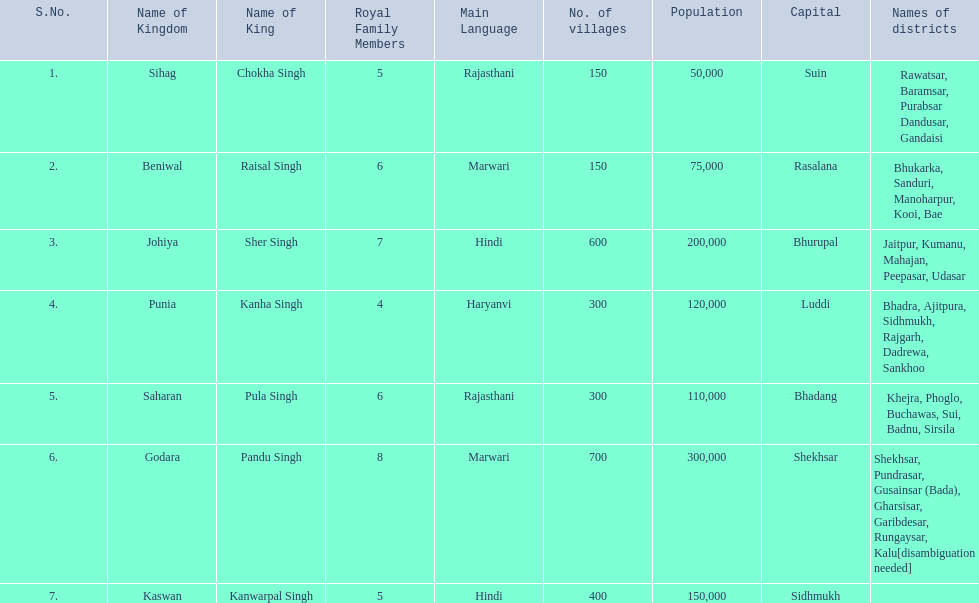Which kingdom contained the least amount of villages along with sihag? Beniwal. Which kingdom contained the most villages? Godara. Which village was tied at second most villages with godara? Johiya. 